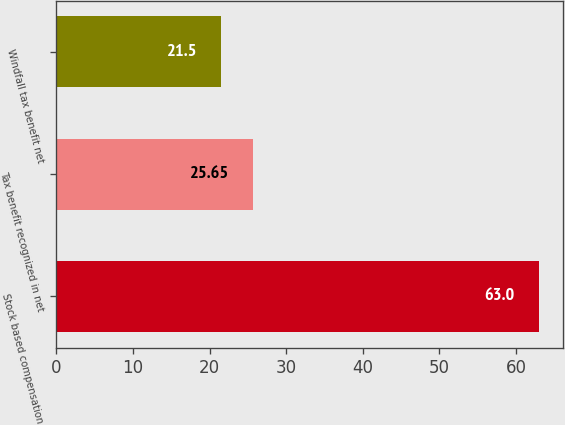Convert chart to OTSL. <chart><loc_0><loc_0><loc_500><loc_500><bar_chart><fcel>Stock based compensation<fcel>Tax benefit recognized in net<fcel>Windfall tax benefit net<nl><fcel>63<fcel>25.65<fcel>21.5<nl></chart> 